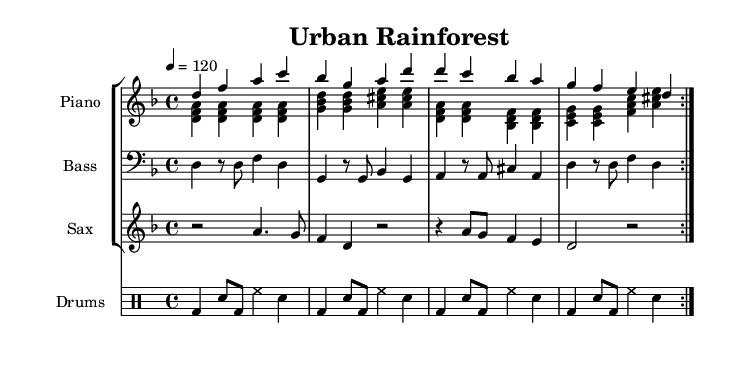What is the key signature of this music? The key signature is D minor, indicated by one flat (B♭) in the music.
Answer: D minor What is the time signature of this music? The time signature is 4/4, which is shown by the markings at the beginning of the piece.
Answer: 4/4 What is the tempo marking for this piece? The tempo marking is quarter note equals 120, which sets the pace for the performance.
Answer: 120 How many measures are repeated in the piece? The piece indicates that there are 2 measures repeated for both the piano and the saxophone sections.
Answer: 2 What instruments are featured in this arrangement? The arrangement features piano, bass, saxophone, and drums, as indicated by the staff labels.
Answer: Piano, bass, saxophone, drums Describe the rhythm of the drum part. The drum part contains a bass drum and snare drum pattern that repeats with eighth notes followed by a quarter note, creating a steady driving rhythm.
Answer: Steady driving rhythm What fusion style does this piece represent? This piece represents Afro-Latin fusion rhythms, blending elements of Latin music with African rhythmic structures, supporting the theme of urban landscapes.
Answer: Afro-Latin fusion 